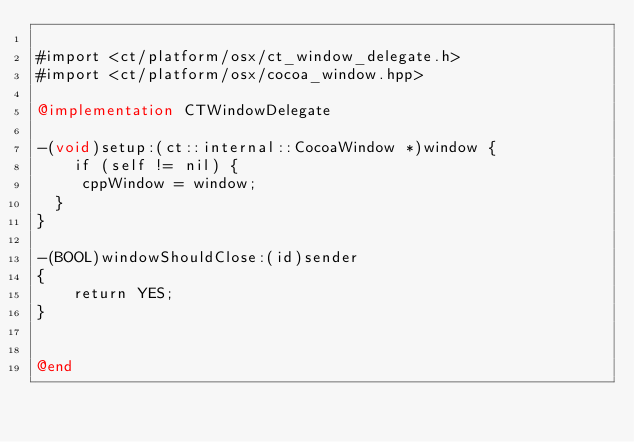Convert code to text. <code><loc_0><loc_0><loc_500><loc_500><_ObjectiveC_>
#import <ct/platform/osx/ct_window_delegate.h>
#import <ct/platform/osx/cocoa_window.hpp>

@implementation CTWindowDelegate

-(void)setup:(ct::internal::CocoaWindow *)window {
    if (self != nil) {
		 cppWindow = window;
	}
}

-(BOOL)windowShouldClose:(id)sender
{
    return YES;
}


@end
</code> 